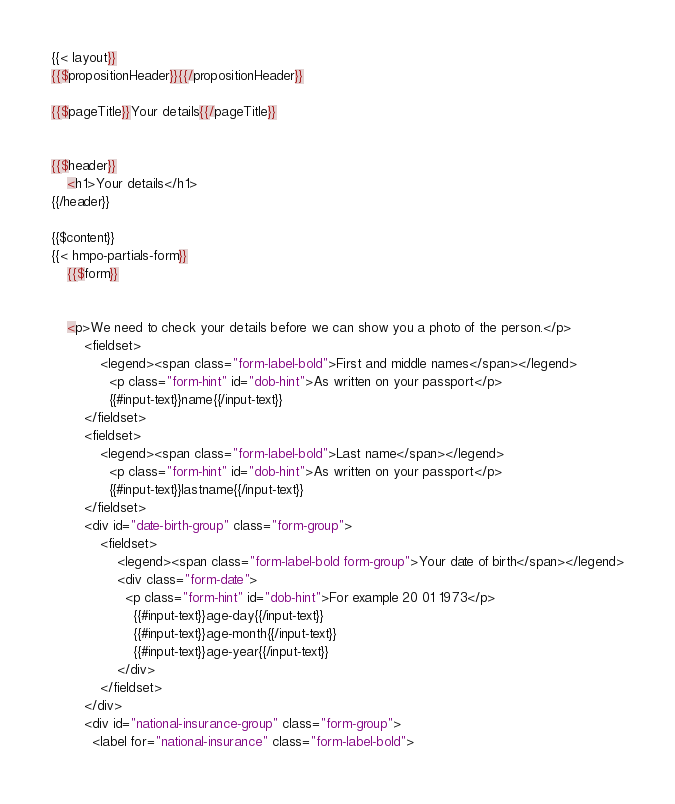Convert code to text. <code><loc_0><loc_0><loc_500><loc_500><_HTML_>{{< layout}}
{{$propositionHeader}}{{/propositionHeader}}

{{$pageTitle}}Your details{{/pageTitle}}


{{$header}}
    <h1>Your details</h1>
{{/header}}

{{$content}}
{{< hmpo-partials-form}}
    {{$form}}


    <p>We need to check your details before we can show you a photo of the person.</p>
        <fieldset>
            <legend><span class="form-label-bold">First and middle names</span></legend>
              <p class="form-hint" id="dob-hint">As written on your passport</p>
              {{#input-text}}name{{/input-text}}
        </fieldset>
        <fieldset>
            <legend><span class="form-label-bold">Last name</span></legend>
              <p class="form-hint" id="dob-hint">As written on your passport</p>
              {{#input-text}}lastname{{/input-text}}
        </fieldset>
        <div id="date-birth-group" class="form-group">
            <fieldset>
                <legend><span class="form-label-bold form-group">Your date of birth</span></legend>
                <div class="form-date">
                  <p class="form-hint" id="dob-hint">For example 20 01 1973</p>
                    {{#input-text}}age-day{{/input-text}}
                    {{#input-text}}age-month{{/input-text}}
                    {{#input-text}}age-year{{/input-text}}
                </div>
            </fieldset>
        </div>
        <div id="national-insurance-group" class="form-group">
          <label for="national-insurance" class="form-label-bold"></code> 